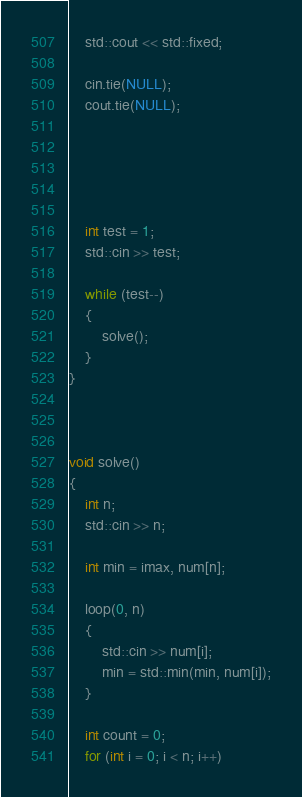<code> <loc_0><loc_0><loc_500><loc_500><_C++_>    std::cout << std::fixed;

    cin.tie(NULL);
    cout.tie(NULL);

    

    

    int test = 1;
    std::cin >> test;

    while (test--)
    {
        solve();
    }
}



void solve()
{
    int n;
    std::cin >> n;

    int min = imax, num[n];

    loop(0, n)
    {
        std::cin >> num[i];
        min = std::min(min, num[i]);
    }

    int count = 0;
    for (int i = 0; i < n; i++)</code> 